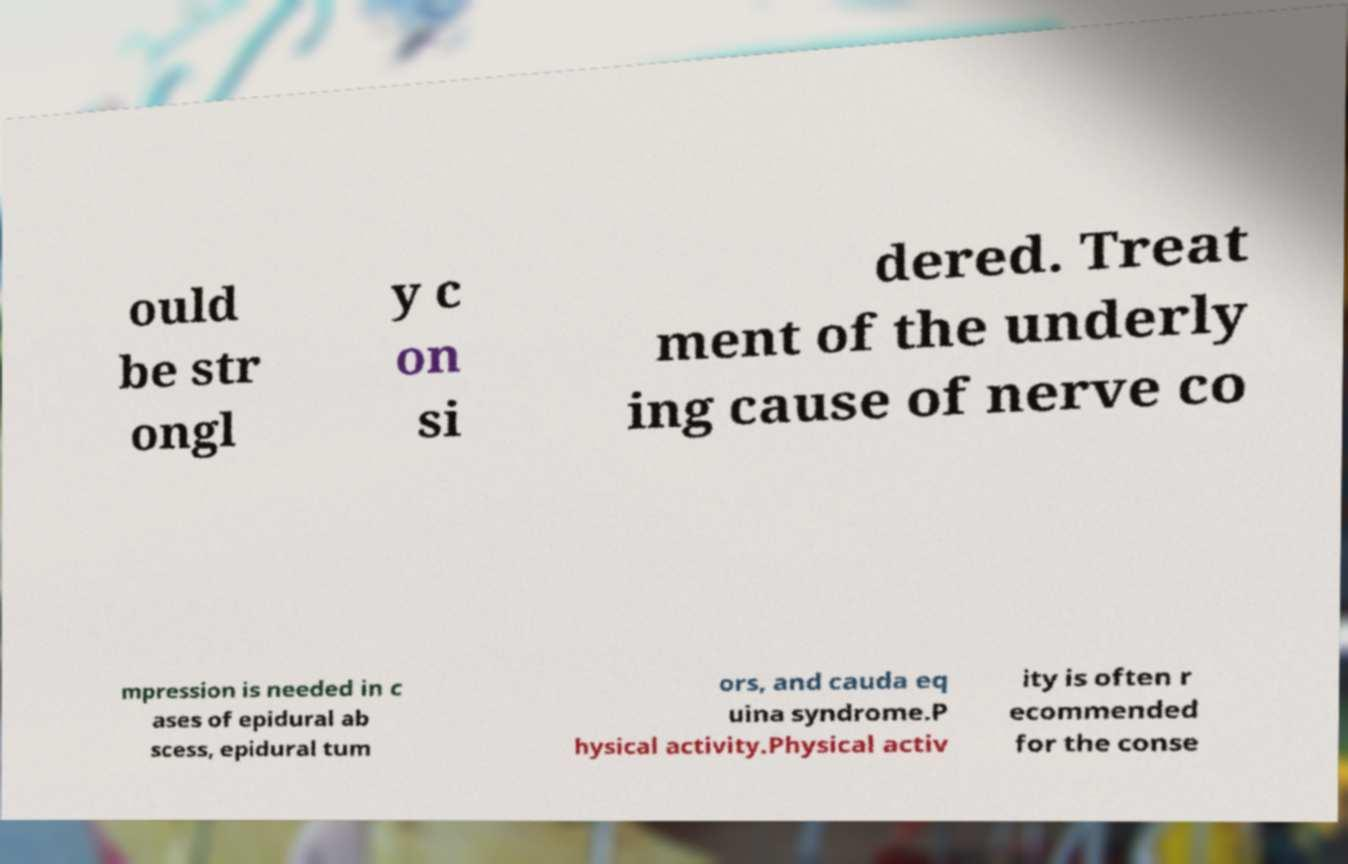Could you extract and type out the text from this image? ould be str ongl y c on si dered. Treat ment of the underly ing cause of nerve co mpression is needed in c ases of epidural ab scess, epidural tum ors, and cauda eq uina syndrome.P hysical activity.Physical activ ity is often r ecommended for the conse 